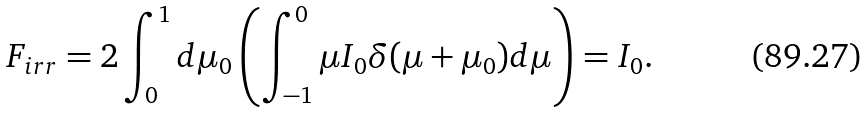Convert formula to latex. <formula><loc_0><loc_0><loc_500><loc_500>F _ { i r r } = 2 \int _ { 0 } ^ { 1 } d \mu _ { 0 } \left ( \int _ { - 1 } ^ { 0 } \mu I _ { 0 } \delta ( \mu + \mu _ { 0 } ) d \mu \right ) = I _ { 0 } .</formula> 